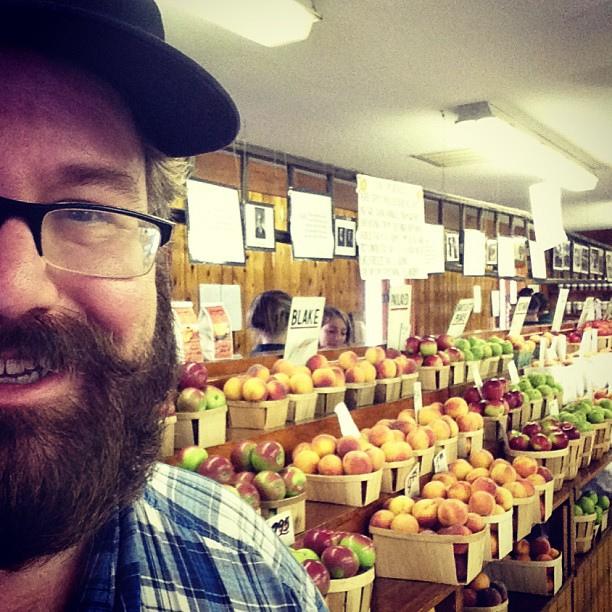Is he in the drink aisle?
Keep it brief. No. Why are there baskets of fruit set up in the room?
Keep it brief. Grocery store. Where is the photo taken?
Concise answer only. Market. Did the man shave today?
Write a very short answer. No. 